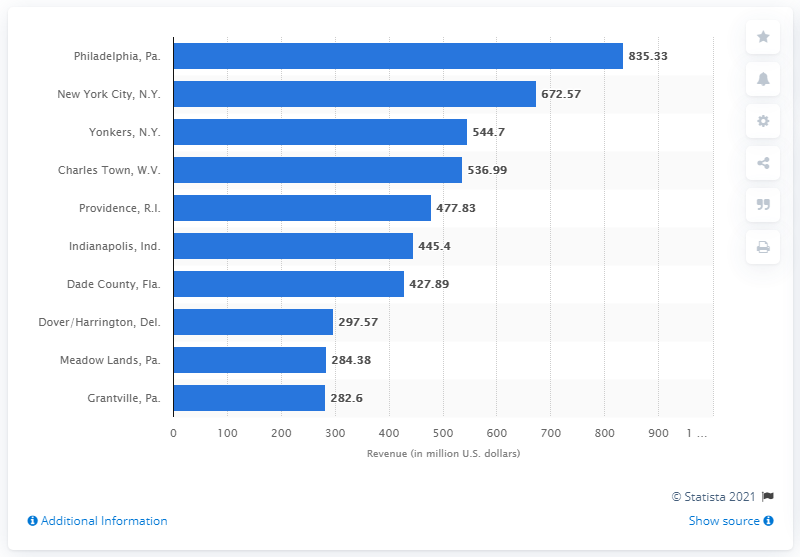Point out several critical features in this image. The total revenue generated by racetrack casinos in Dade County, Florida in 2012 was $427.89 million. 